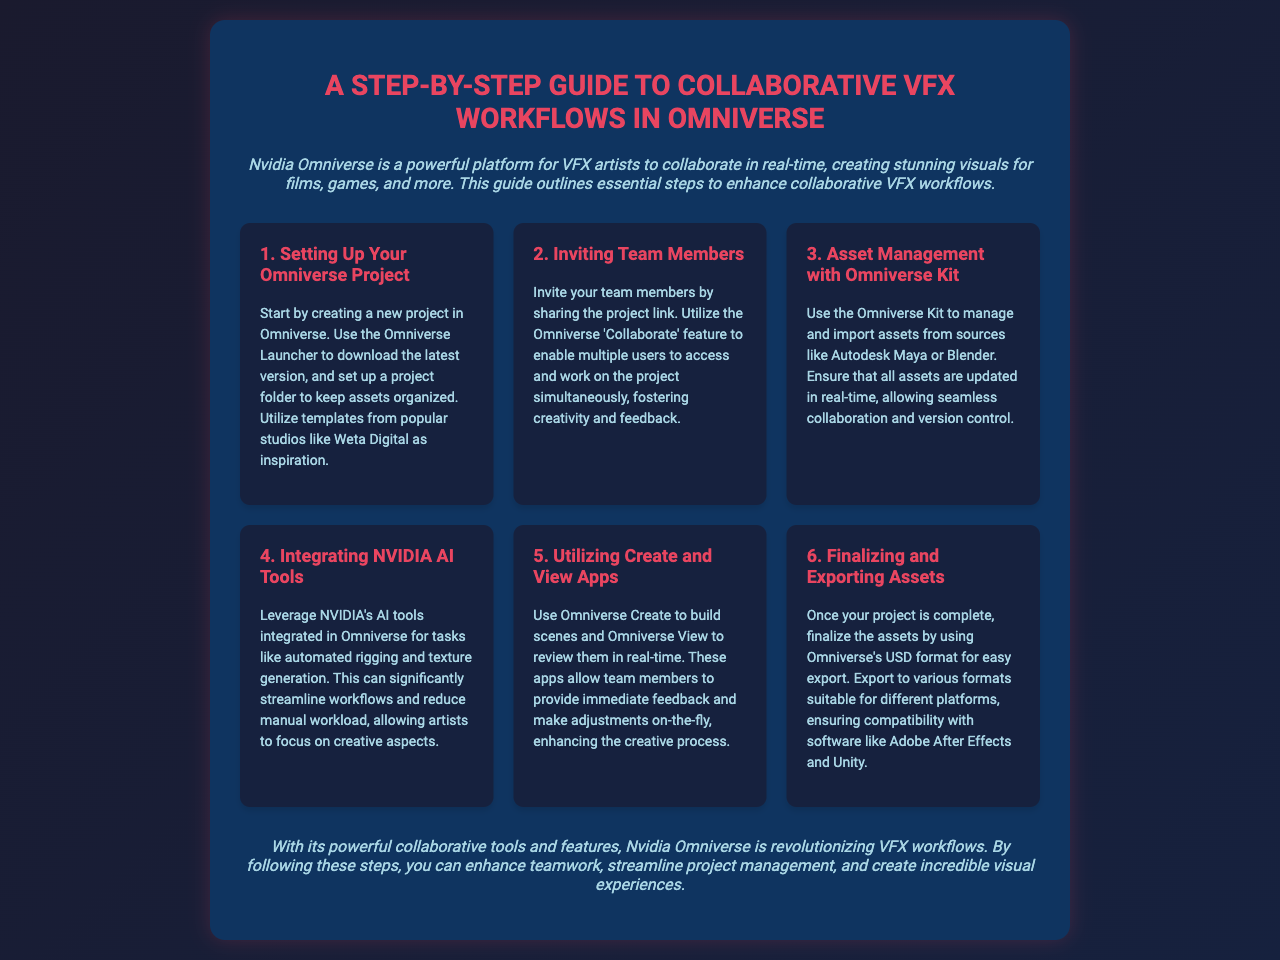What is the title of the guide? The title is provided in the heading of the brochure at the top.
Answer: A Step-by-Step Guide to Collaborative VFX Workflows in Omniverse What platform is discussed in the guide? The introduction mentions the key platform for VFX artists.
Answer: Nvidia Omniverse How many steps are outlined in the guide? The steps are numbered from 1 to 6, indicating the total count.
Answer: 6 Which tool is used for asset management? The guide specifies the tool used for managing and importing assets.
Answer: Omniverse Kit What feature allows team members to collaborate? The guide highlights a specific feature that facilitates teamwork and accessibility.
Answer: Collaborate What does the Omniverse Create app enable? The guide explains the function of the Omniverse Create app.
Answer: Build scenes What format is recommended for exporting assets? The finalization process in the guide suggests a specific format for exports.
Answer: USD format How can workflows be streamlined according to the guide? The guide mentions a specific type of technology that allows for efficiency in workflows.
Answer: NVIDIA AI tools What color scheme is predominately used in the brochure? The overall color design of the brochure can be noted from its style.
Answer: Blue and pink 